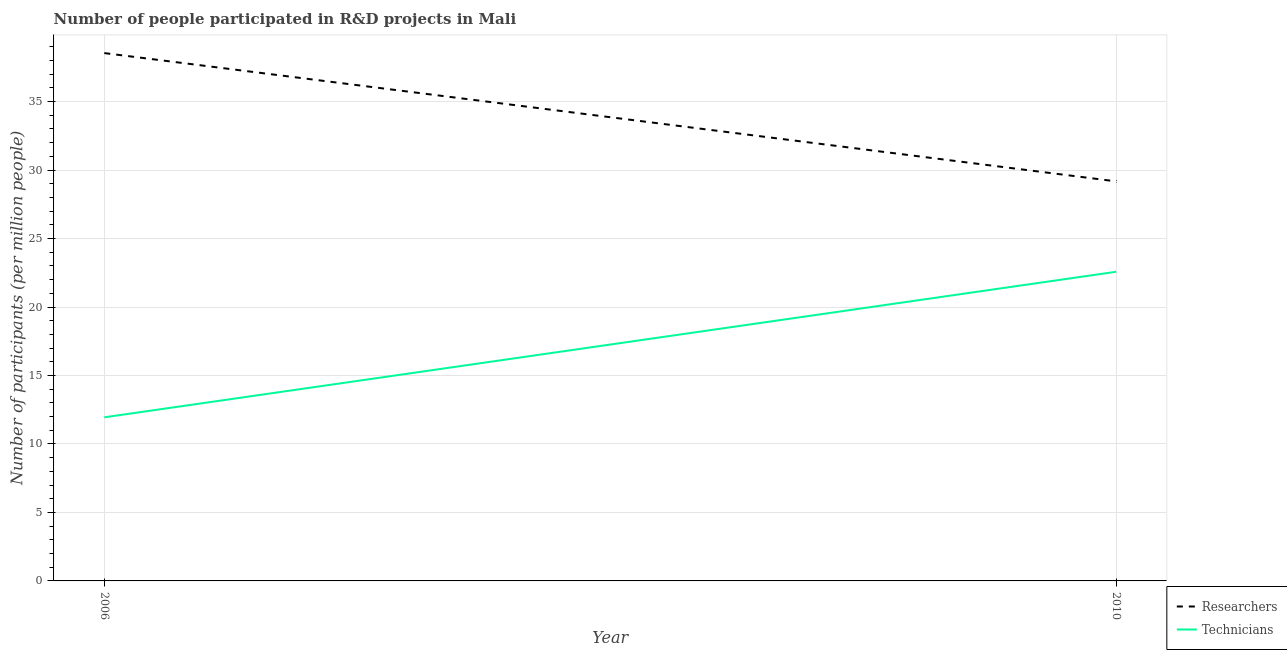Is the number of lines equal to the number of legend labels?
Give a very brief answer. Yes. What is the number of technicians in 2006?
Provide a succinct answer. 11.95. Across all years, what is the maximum number of technicians?
Your response must be concise. 22.57. Across all years, what is the minimum number of researchers?
Your response must be concise. 29.17. What is the total number of technicians in the graph?
Provide a short and direct response. 34.52. What is the difference between the number of technicians in 2006 and that in 2010?
Provide a succinct answer. -10.63. What is the difference between the number of researchers in 2010 and the number of technicians in 2006?
Provide a succinct answer. 17.23. What is the average number of researchers per year?
Keep it short and to the point. 33.86. In the year 2006, what is the difference between the number of technicians and number of researchers?
Give a very brief answer. -26.6. In how many years, is the number of researchers greater than 26?
Your response must be concise. 2. What is the ratio of the number of researchers in 2006 to that in 2010?
Provide a short and direct response. 1.32. Is the number of researchers in 2006 less than that in 2010?
Ensure brevity in your answer.  No. In how many years, is the number of technicians greater than the average number of technicians taken over all years?
Provide a succinct answer. 1. Is the number of technicians strictly greater than the number of researchers over the years?
Your answer should be very brief. No. How many lines are there?
Your response must be concise. 2. How many years are there in the graph?
Make the answer very short. 2. Does the graph contain any zero values?
Your answer should be compact. No. Does the graph contain grids?
Offer a terse response. Yes. Where does the legend appear in the graph?
Offer a terse response. Bottom right. How are the legend labels stacked?
Make the answer very short. Vertical. What is the title of the graph?
Offer a terse response. Number of people participated in R&D projects in Mali. What is the label or title of the X-axis?
Provide a succinct answer. Year. What is the label or title of the Y-axis?
Provide a short and direct response. Number of participants (per million people). What is the Number of participants (per million people) in Researchers in 2006?
Make the answer very short. 38.54. What is the Number of participants (per million people) of Technicians in 2006?
Offer a very short reply. 11.95. What is the Number of participants (per million people) of Researchers in 2010?
Your answer should be compact. 29.17. What is the Number of participants (per million people) in Technicians in 2010?
Provide a short and direct response. 22.57. Across all years, what is the maximum Number of participants (per million people) of Researchers?
Your answer should be very brief. 38.54. Across all years, what is the maximum Number of participants (per million people) of Technicians?
Ensure brevity in your answer.  22.57. Across all years, what is the minimum Number of participants (per million people) in Researchers?
Ensure brevity in your answer.  29.17. Across all years, what is the minimum Number of participants (per million people) of Technicians?
Your response must be concise. 11.95. What is the total Number of participants (per million people) in Researchers in the graph?
Provide a short and direct response. 67.72. What is the total Number of participants (per million people) of Technicians in the graph?
Provide a succinct answer. 34.52. What is the difference between the Number of participants (per million people) of Researchers in 2006 and that in 2010?
Your response must be concise. 9.37. What is the difference between the Number of participants (per million people) of Technicians in 2006 and that in 2010?
Your response must be concise. -10.63. What is the difference between the Number of participants (per million people) in Researchers in 2006 and the Number of participants (per million people) in Technicians in 2010?
Your answer should be very brief. 15.97. What is the average Number of participants (per million people) in Researchers per year?
Ensure brevity in your answer.  33.86. What is the average Number of participants (per million people) in Technicians per year?
Provide a short and direct response. 17.26. In the year 2006, what is the difference between the Number of participants (per million people) in Researchers and Number of participants (per million people) in Technicians?
Provide a short and direct response. 26.6. In the year 2010, what is the difference between the Number of participants (per million people) in Researchers and Number of participants (per million people) in Technicians?
Provide a succinct answer. 6.6. What is the ratio of the Number of participants (per million people) of Researchers in 2006 to that in 2010?
Make the answer very short. 1.32. What is the ratio of the Number of participants (per million people) of Technicians in 2006 to that in 2010?
Your response must be concise. 0.53. What is the difference between the highest and the second highest Number of participants (per million people) in Researchers?
Ensure brevity in your answer.  9.37. What is the difference between the highest and the second highest Number of participants (per million people) of Technicians?
Keep it short and to the point. 10.63. What is the difference between the highest and the lowest Number of participants (per million people) of Researchers?
Keep it short and to the point. 9.37. What is the difference between the highest and the lowest Number of participants (per million people) of Technicians?
Offer a terse response. 10.63. 